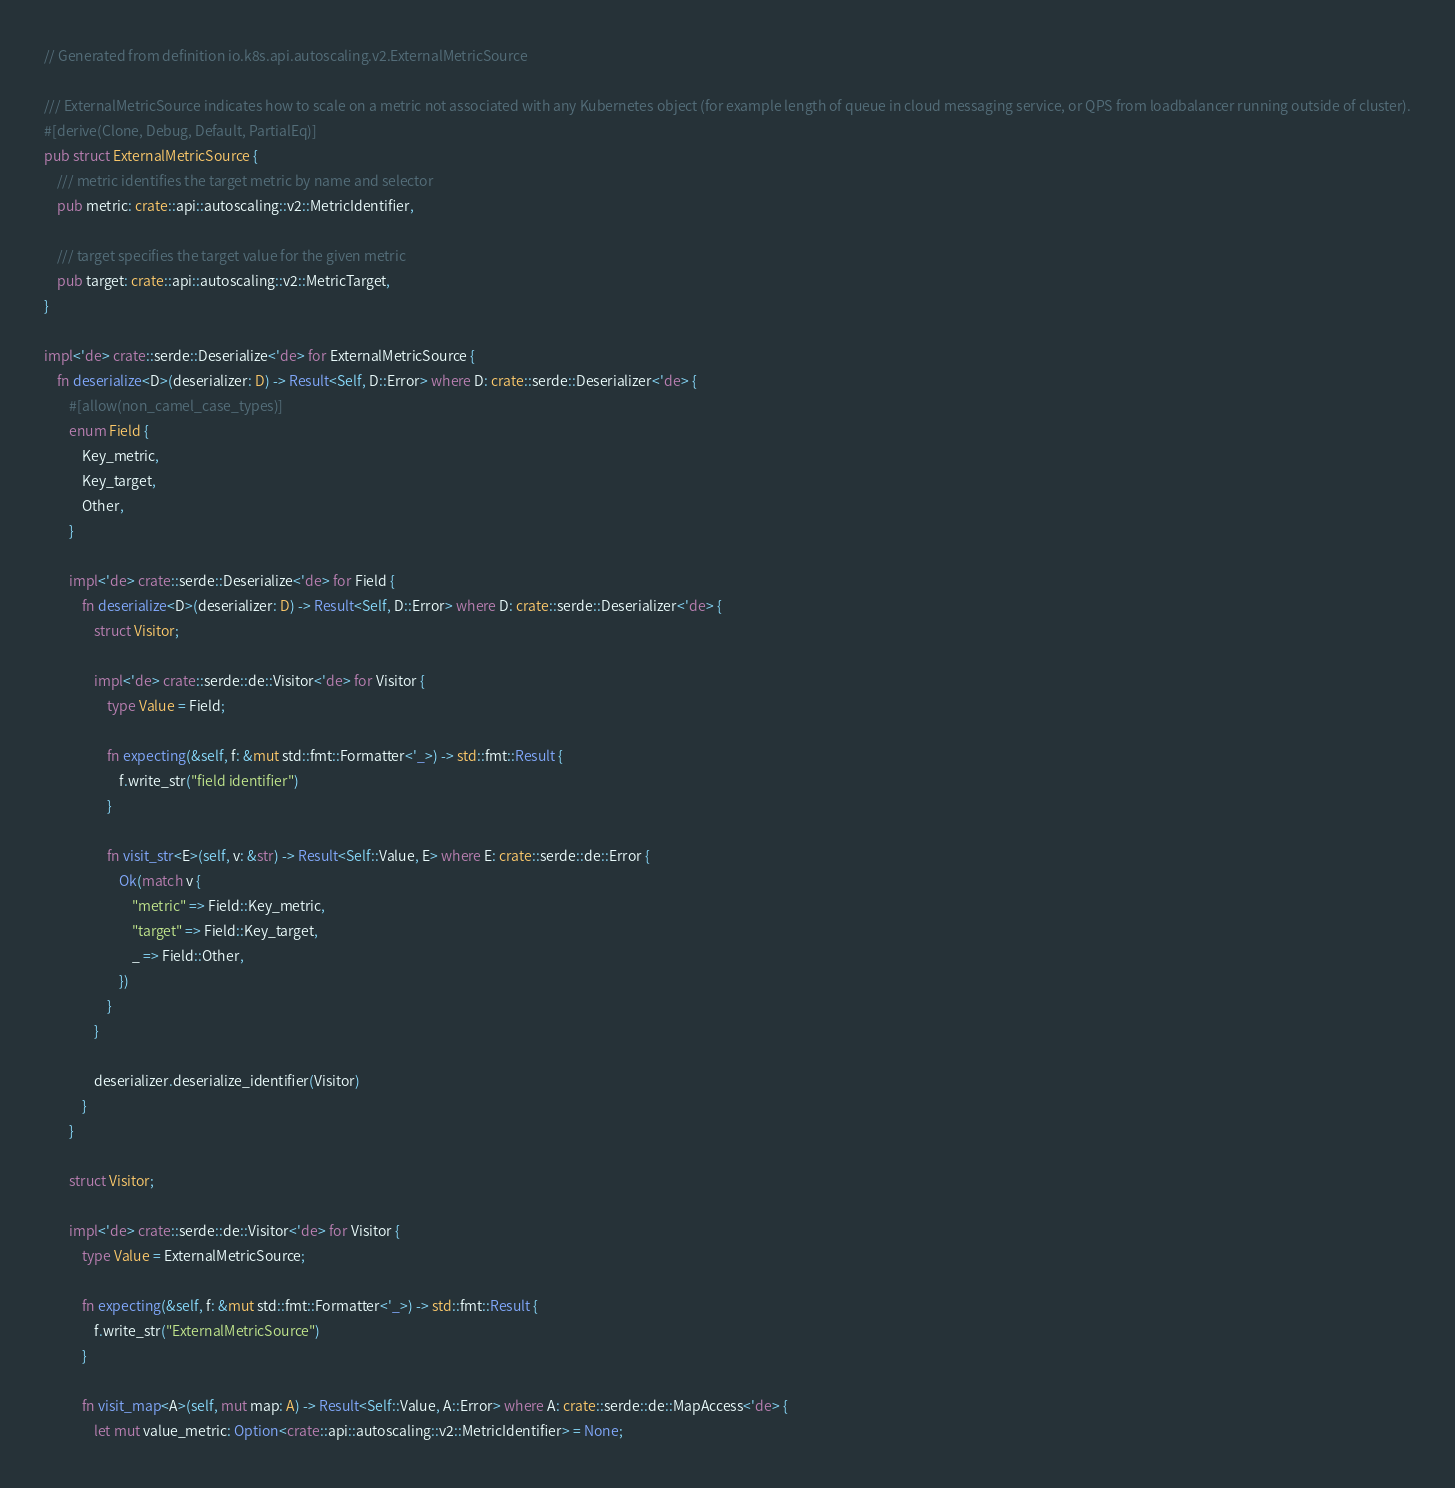<code> <loc_0><loc_0><loc_500><loc_500><_Rust_>// Generated from definition io.k8s.api.autoscaling.v2.ExternalMetricSource

/// ExternalMetricSource indicates how to scale on a metric not associated with any Kubernetes object (for example length of queue in cloud messaging service, or QPS from loadbalancer running outside of cluster).
#[derive(Clone, Debug, Default, PartialEq)]
pub struct ExternalMetricSource {
    /// metric identifies the target metric by name and selector
    pub metric: crate::api::autoscaling::v2::MetricIdentifier,

    /// target specifies the target value for the given metric
    pub target: crate::api::autoscaling::v2::MetricTarget,
}

impl<'de> crate::serde::Deserialize<'de> for ExternalMetricSource {
    fn deserialize<D>(deserializer: D) -> Result<Self, D::Error> where D: crate::serde::Deserializer<'de> {
        #[allow(non_camel_case_types)]
        enum Field {
            Key_metric,
            Key_target,
            Other,
        }

        impl<'de> crate::serde::Deserialize<'de> for Field {
            fn deserialize<D>(deserializer: D) -> Result<Self, D::Error> where D: crate::serde::Deserializer<'de> {
                struct Visitor;

                impl<'de> crate::serde::de::Visitor<'de> for Visitor {
                    type Value = Field;

                    fn expecting(&self, f: &mut std::fmt::Formatter<'_>) -> std::fmt::Result {
                        f.write_str("field identifier")
                    }

                    fn visit_str<E>(self, v: &str) -> Result<Self::Value, E> where E: crate::serde::de::Error {
                        Ok(match v {
                            "metric" => Field::Key_metric,
                            "target" => Field::Key_target,
                            _ => Field::Other,
                        })
                    }
                }

                deserializer.deserialize_identifier(Visitor)
            }
        }

        struct Visitor;

        impl<'de> crate::serde::de::Visitor<'de> for Visitor {
            type Value = ExternalMetricSource;

            fn expecting(&self, f: &mut std::fmt::Formatter<'_>) -> std::fmt::Result {
                f.write_str("ExternalMetricSource")
            }

            fn visit_map<A>(self, mut map: A) -> Result<Self::Value, A::Error> where A: crate::serde::de::MapAccess<'de> {
                let mut value_metric: Option<crate::api::autoscaling::v2::MetricIdentifier> = None;</code> 